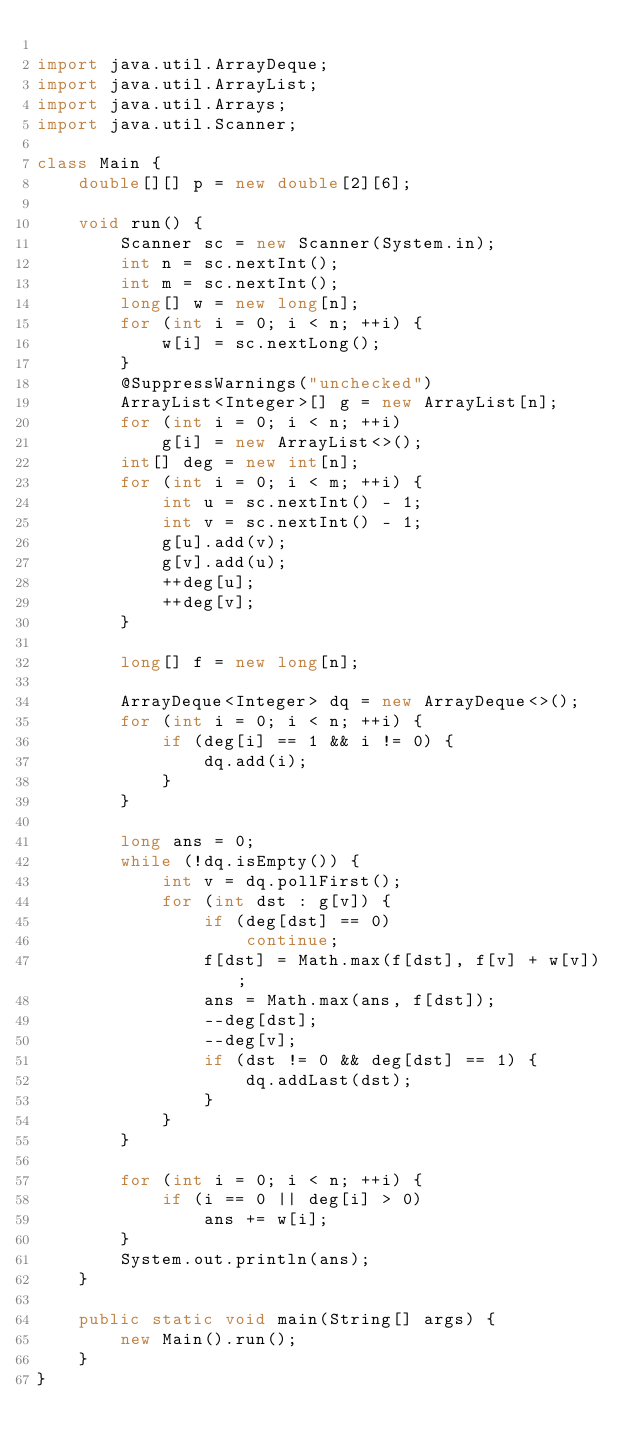Convert code to text. <code><loc_0><loc_0><loc_500><loc_500><_Java_>
import java.util.ArrayDeque;
import java.util.ArrayList;
import java.util.Arrays;
import java.util.Scanner;

class Main {
	double[][] p = new double[2][6];

	void run() {
		Scanner sc = new Scanner(System.in);
		int n = sc.nextInt();
		int m = sc.nextInt();
		long[] w = new long[n];
		for (int i = 0; i < n; ++i) {
			w[i] = sc.nextLong();
		}
		@SuppressWarnings("unchecked")
		ArrayList<Integer>[] g = new ArrayList[n];
		for (int i = 0; i < n; ++i)
			g[i] = new ArrayList<>();
		int[] deg = new int[n];
		for (int i = 0; i < m; ++i) {
			int u = sc.nextInt() - 1;
			int v = sc.nextInt() - 1;
			g[u].add(v);
			g[v].add(u);
			++deg[u];
			++deg[v];
		}

		long[] f = new long[n];

		ArrayDeque<Integer> dq = new ArrayDeque<>();
		for (int i = 0; i < n; ++i) {
			if (deg[i] == 1 && i != 0) {
				dq.add(i);
			}
		}

		long ans = 0;
		while (!dq.isEmpty()) {
			int v = dq.pollFirst();
			for (int dst : g[v]) {
				if (deg[dst] == 0)
					continue;
				f[dst] = Math.max(f[dst], f[v] + w[v]);
				ans = Math.max(ans, f[dst]);
				--deg[dst];
				--deg[v];
				if (dst != 0 && deg[dst] == 1) {
					dq.addLast(dst);
				}
			}
		}

		for (int i = 0; i < n; ++i) {
			if (i == 0 || deg[i] > 0)
				ans += w[i];
		}
		System.out.println(ans);
	}

	public static void main(String[] args) {
		new Main().run();
	}
}
</code> 